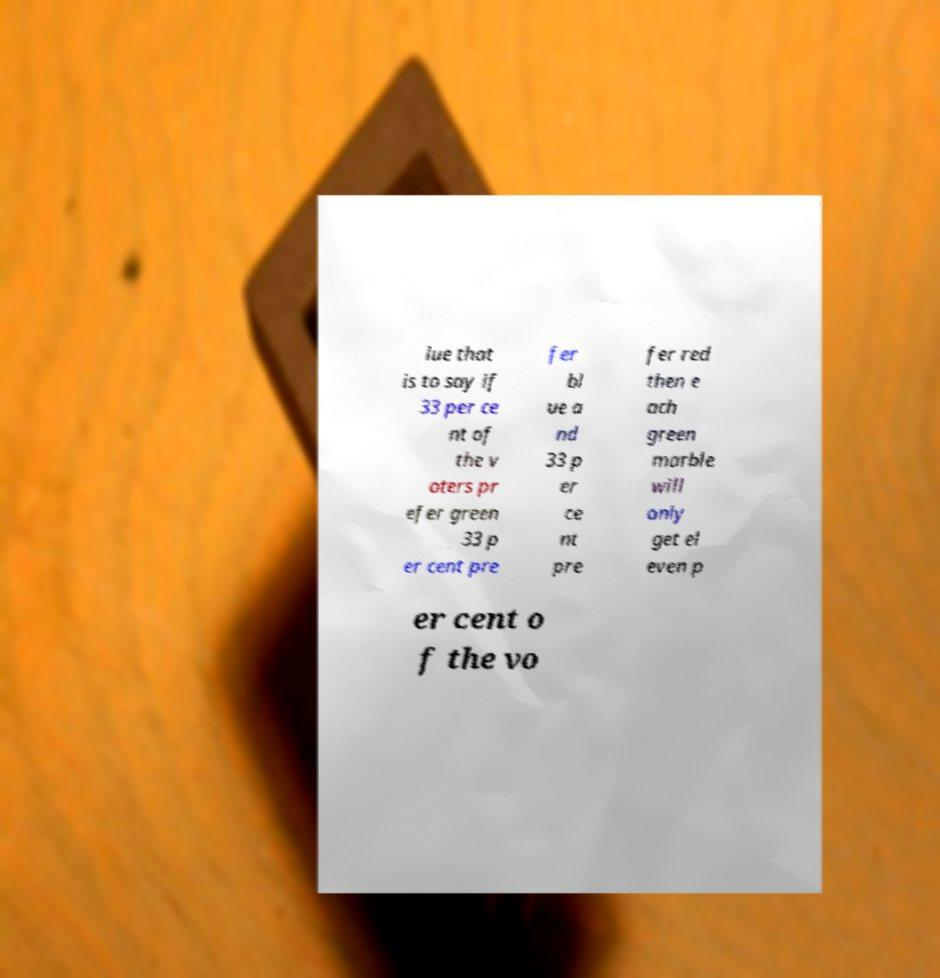Can you accurately transcribe the text from the provided image for me? lue that is to say if 33 per ce nt of the v oters pr efer green 33 p er cent pre fer bl ue a nd 33 p er ce nt pre fer red then e ach green marble will only get el even p er cent o f the vo 